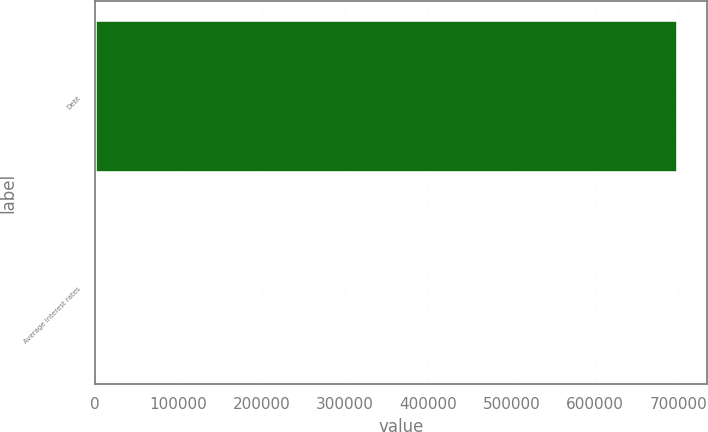Convert chart. <chart><loc_0><loc_0><loc_500><loc_500><bar_chart><fcel>Debt<fcel>Average interest rates<nl><fcel>699550<fcel>4.9<nl></chart> 